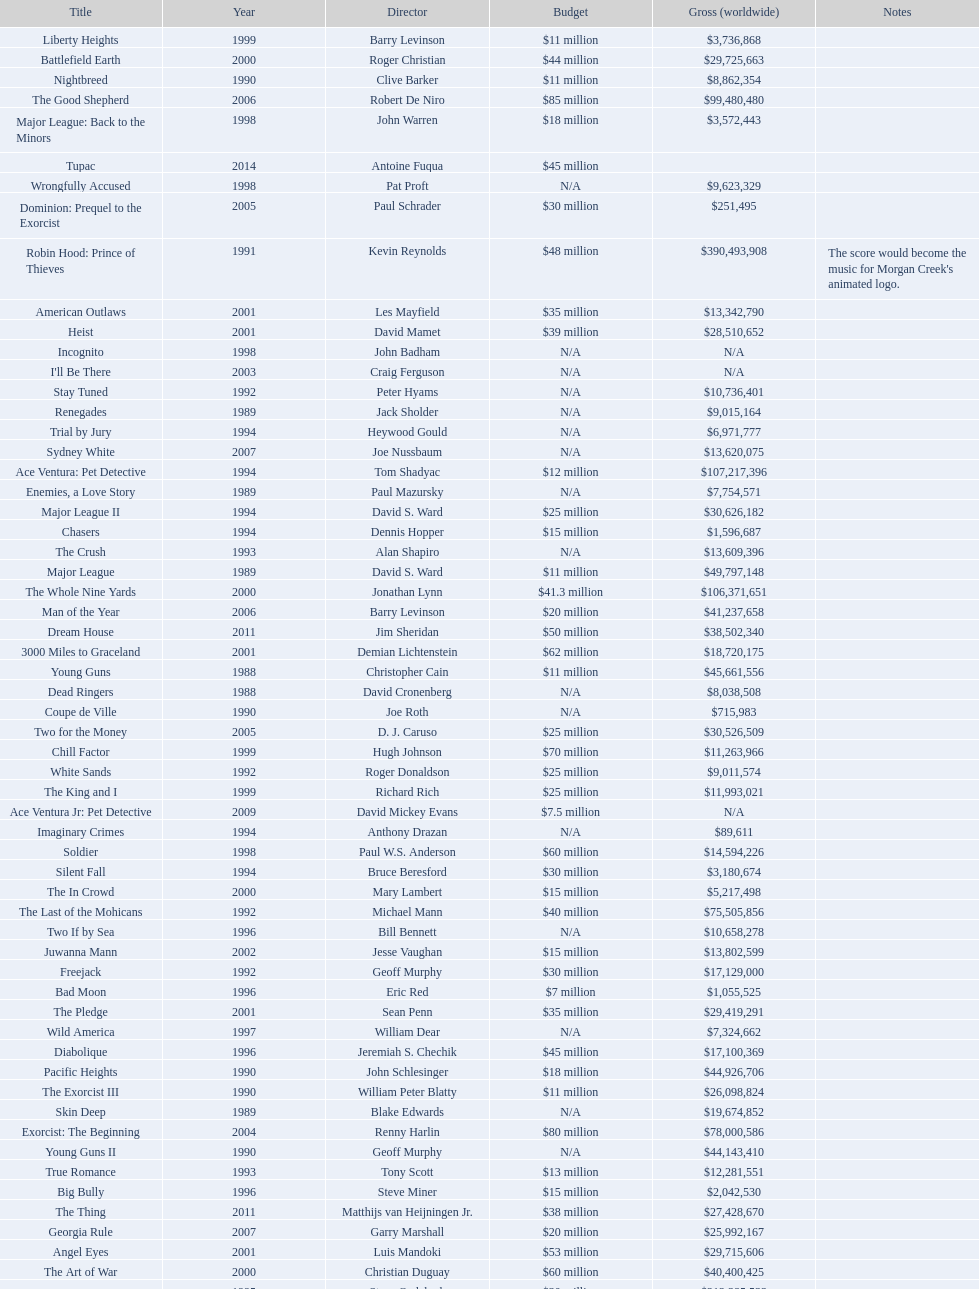What was the last movie morgan creek made for a budget under thirty million? Ace Ventura Jr: Pet Detective. 